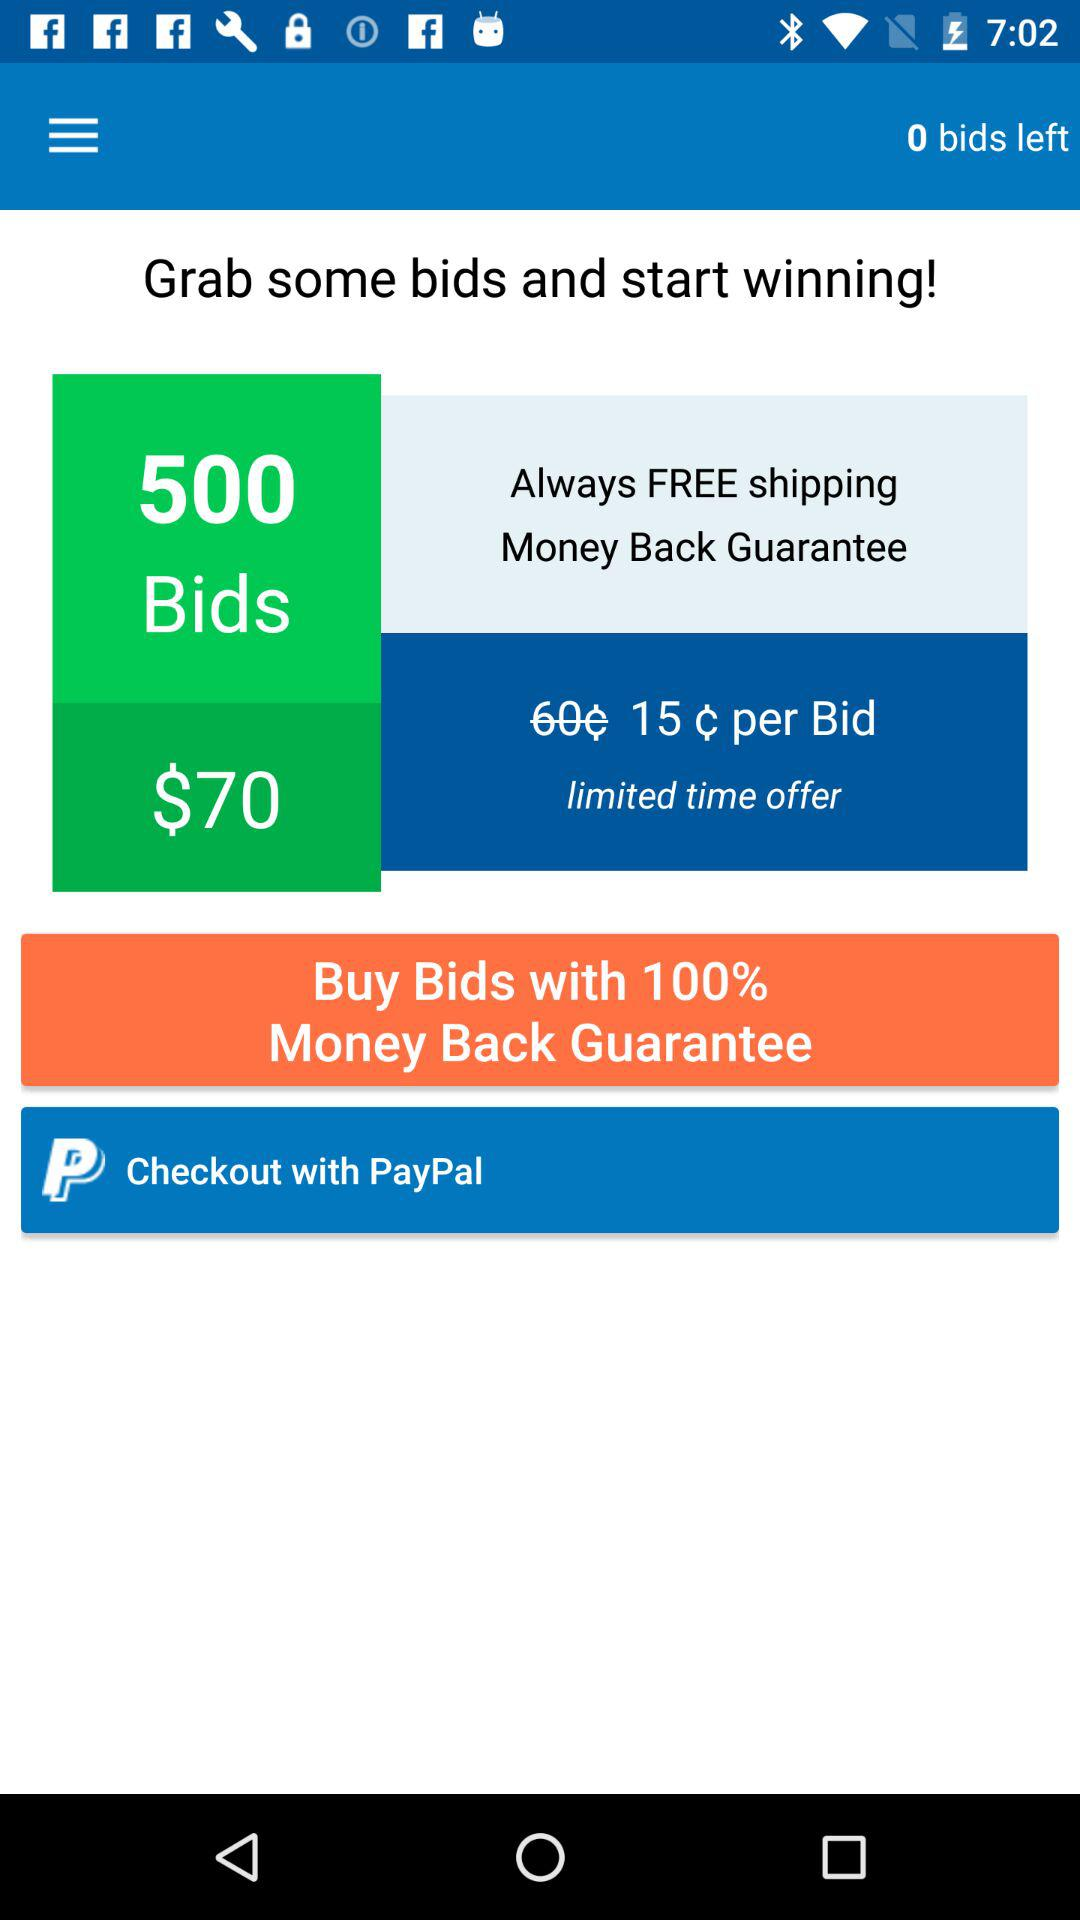What is the payment method? The payment method is "PayPal". 